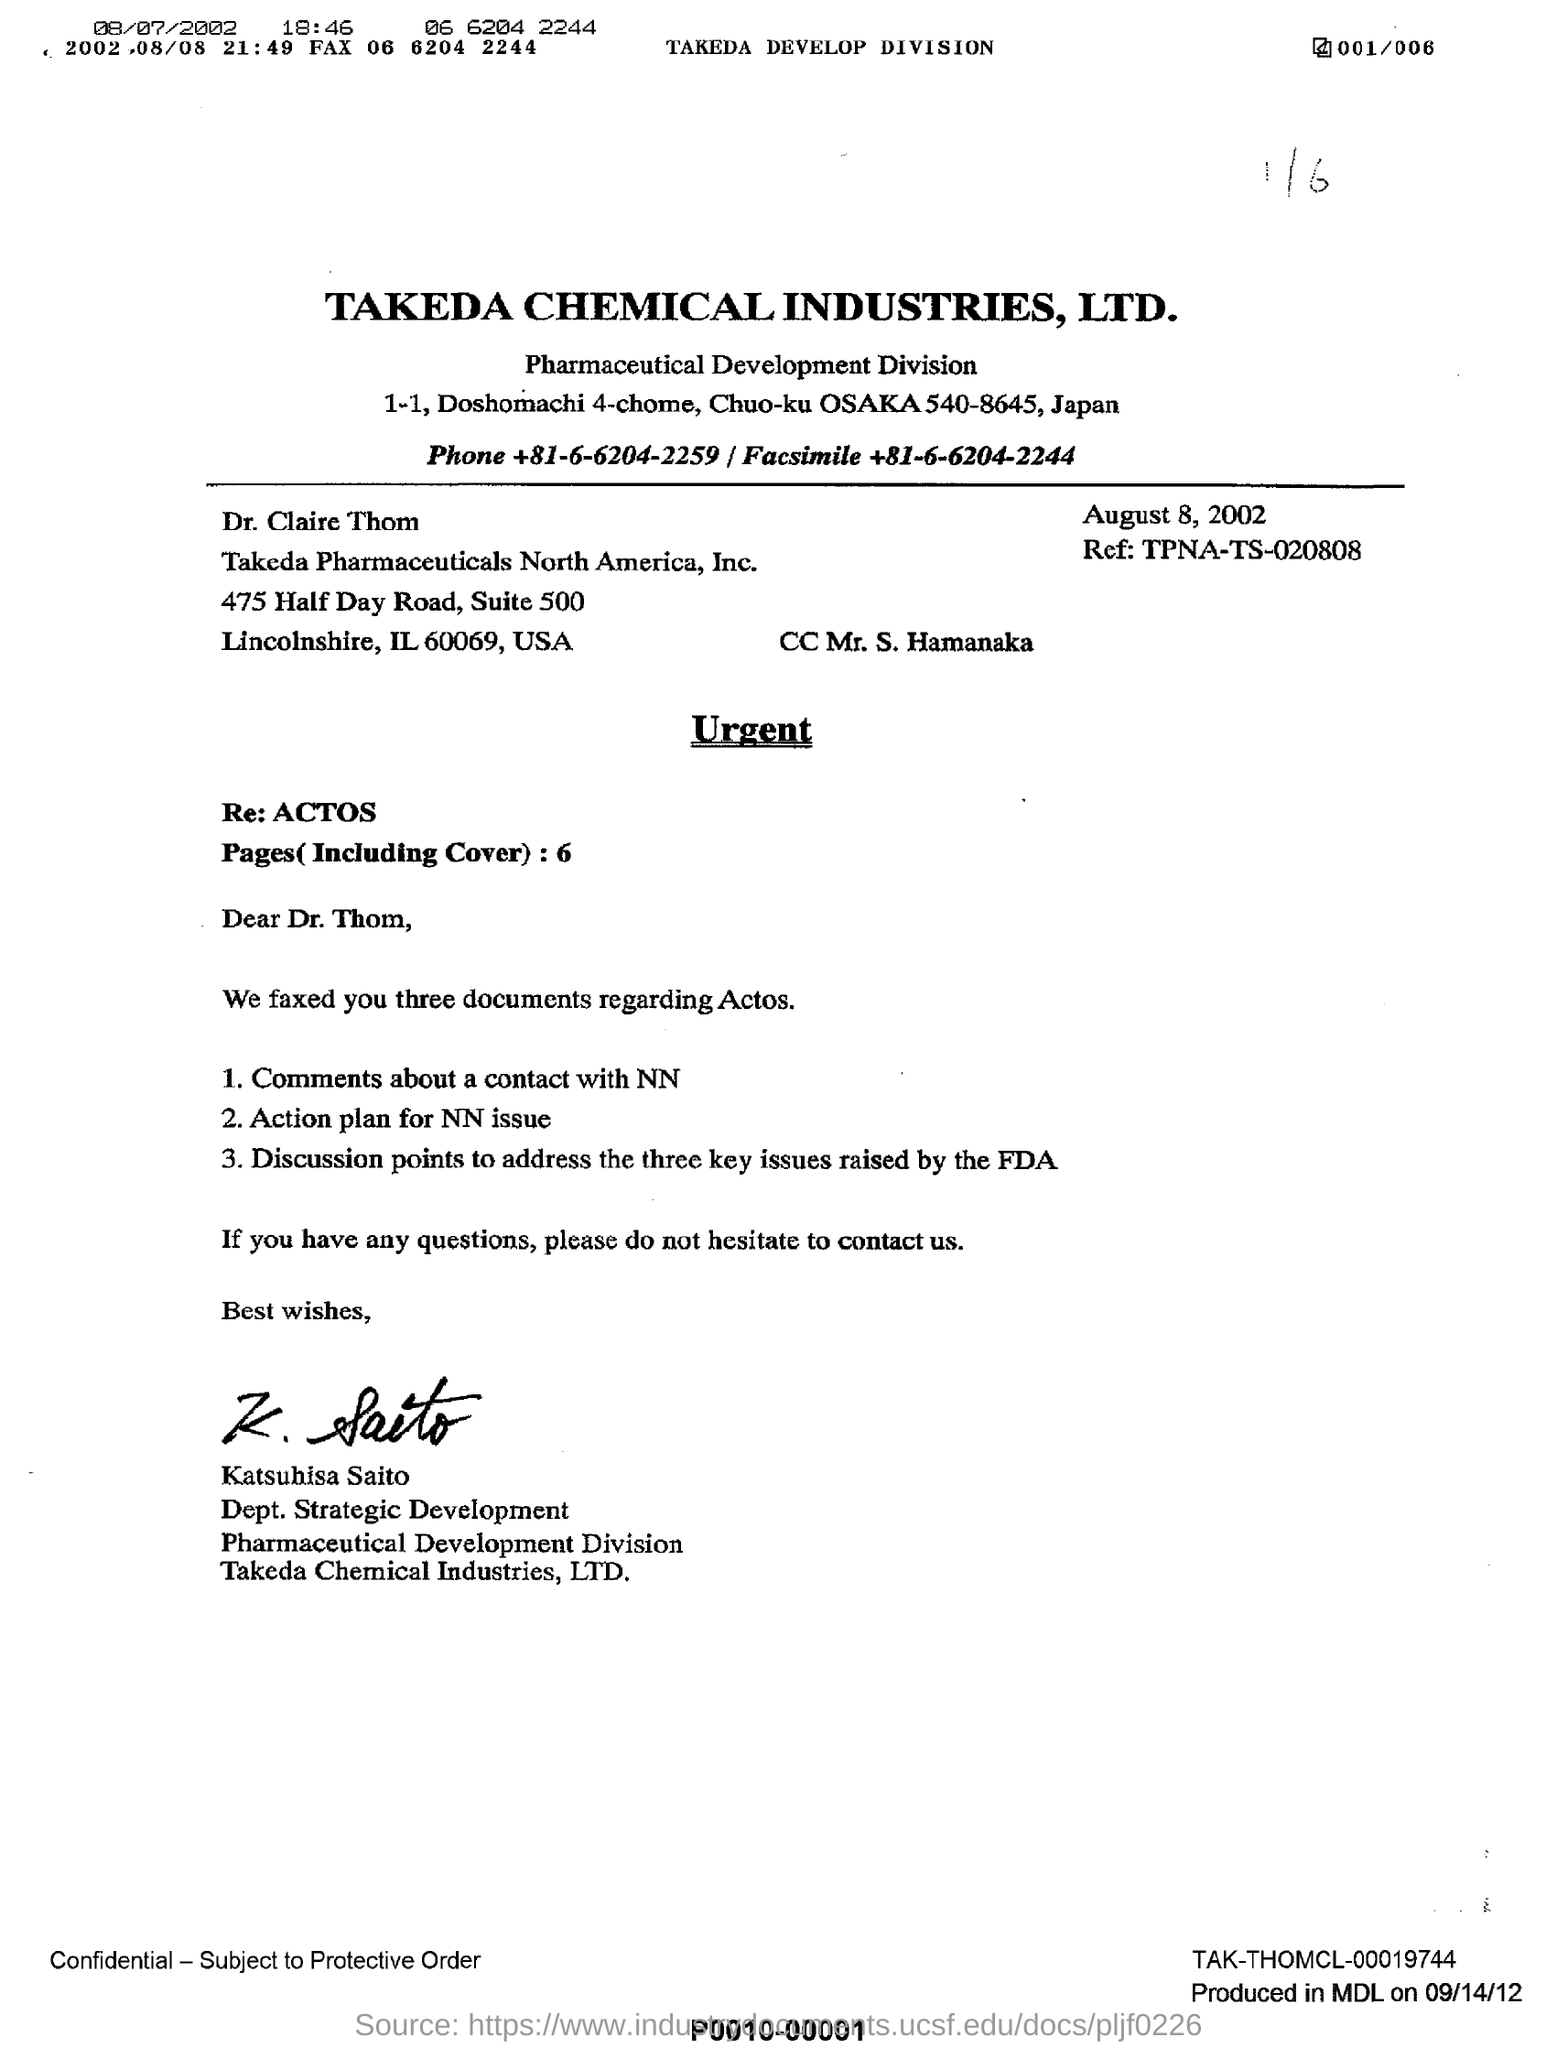Highlight a few significant elements in this photo. The letter is written to Dr. Claire Thom. The name "Mr. S. Hamanaka" is mentioned in CC. The date mentioned in the letter is August 8, 2002. Katsuhisa Saito sent the letter. The name of the industry represented by Takeda Chemical Industries, Ltd. is ... 